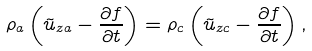Convert formula to latex. <formula><loc_0><loc_0><loc_500><loc_500>\rho _ { a } \left ( \tilde { u } _ { z a } - \frac { \partial f } { \partial t } \right ) = \rho _ { c } \left ( \tilde { u } _ { z c } - \frac { \partial f } { \partial t } \right ) ,</formula> 